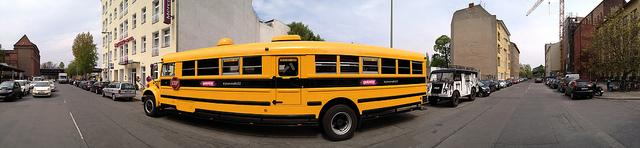What is this yellow bus doing?

Choices:
A) turning left
B) reversing
C) turning right
D) parking turning right 